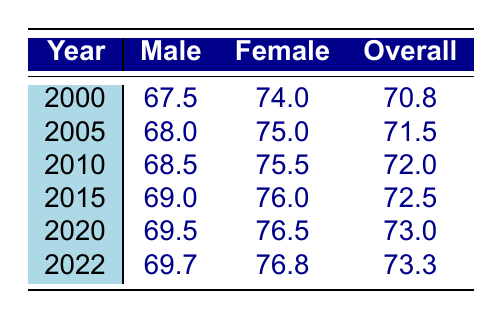What was the life expectancy of males in 2010? The table shows that in the year 2010, the life expectancy for males was 68.5 years, which can be found in the corresponding row and column.
Answer: 68.5 What is the overall life expectancy in 2015? According to the table, the overall life expectancy for the year 2015 is listed as 72.5 years, found in the row for that year.
Answer: 72.5 Which gender had a higher life expectancy in 2022? For the year 2022, the life expectancy for females is 76.8 years, while for males, it is 69.7 years. Since 76.8 is greater than 69.7, females had a higher life expectancy.
Answer: Females What is the difference in life expectancy between males and females in 2020? In 2020, males had a life expectancy of 69.5 years and females had 76.5 years. The difference is calculated as 76.5 - 69.5 = 7.0 years.
Answer: 7.0 Is the overall life expectancy increased from 2010 to 2020? In 2010, the overall life expectancy was 72.0 years, and in 2020 it rose to 73.0 years. Since 73.0 is greater than 72.0, the life expectancy increased.
Answer: Yes What is the average life expectancy for males from 2000 to 2022? To calculate the average, sum the male life expectancies: (67.5 + 68.0 + 68.5 + 69.0 + 69.5 + 69.7) = 413.2. There are 6 data points, so the average is 413.2 / 6 = 68.87.
Answer: 68.87 Was the life expectancy of females higher in 2010 than in 2005? In 2010, the life expectancy for females was 75.5 years, while in 2005 it was 75.0 years. Since 75.5 is greater than 75.0, the statement is true.
Answer: Yes What is the overall life expectancy trend from 2000 to 2022? The life expectancy overall increased from 70.8 years in 2000 to 73.3 years in 2022. This shows an upward trend as the values rise over the years presented.
Answer: Increasing 